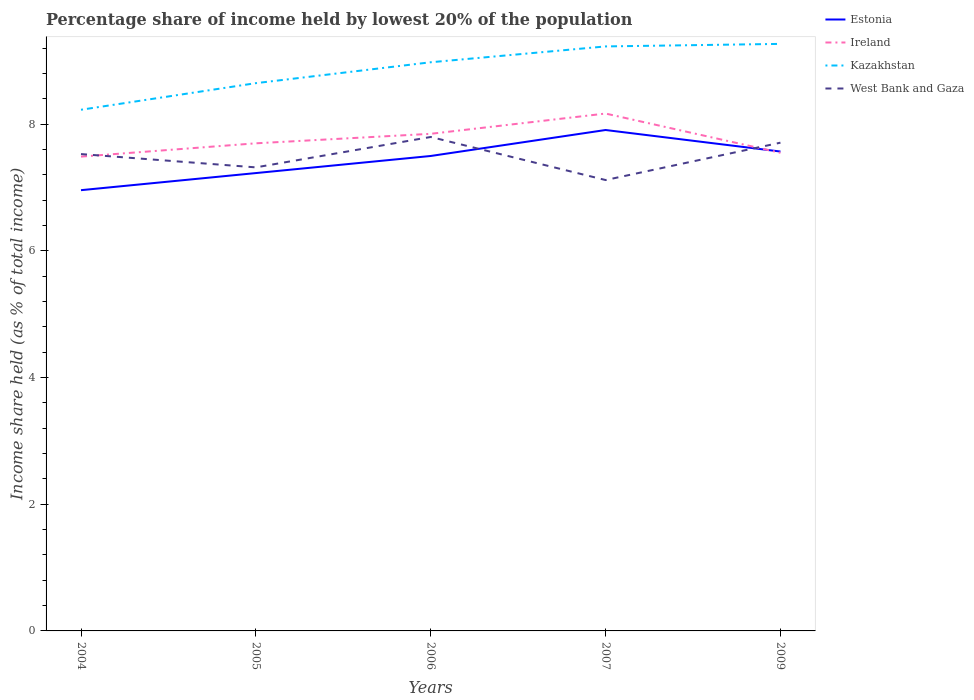How many different coloured lines are there?
Your response must be concise. 4. Does the line corresponding to Estonia intersect with the line corresponding to Kazakhstan?
Keep it short and to the point. No. Across all years, what is the maximum percentage share of income held by lowest 20% of the population in Kazakhstan?
Keep it short and to the point. 8.23. In which year was the percentage share of income held by lowest 20% of the population in Kazakhstan maximum?
Make the answer very short. 2004. What is the total percentage share of income held by lowest 20% of the population in West Bank and Gaza in the graph?
Keep it short and to the point. -0.27. What is the difference between the highest and the second highest percentage share of income held by lowest 20% of the population in Kazakhstan?
Offer a very short reply. 1.04. What is the difference between the highest and the lowest percentage share of income held by lowest 20% of the population in West Bank and Gaza?
Offer a terse response. 3. Does the graph contain grids?
Your response must be concise. No. How many legend labels are there?
Make the answer very short. 4. What is the title of the graph?
Provide a short and direct response. Percentage share of income held by lowest 20% of the population. Does "Suriname" appear as one of the legend labels in the graph?
Offer a very short reply. No. What is the label or title of the Y-axis?
Provide a succinct answer. Income share held (as % of total income). What is the Income share held (as % of total income) in Estonia in 2004?
Ensure brevity in your answer.  6.96. What is the Income share held (as % of total income) of Ireland in 2004?
Provide a succinct answer. 7.49. What is the Income share held (as % of total income) of Kazakhstan in 2004?
Your answer should be very brief. 8.23. What is the Income share held (as % of total income) in West Bank and Gaza in 2004?
Provide a succinct answer. 7.53. What is the Income share held (as % of total income) of Estonia in 2005?
Your answer should be compact. 7.23. What is the Income share held (as % of total income) in Kazakhstan in 2005?
Keep it short and to the point. 8.65. What is the Income share held (as % of total income) in West Bank and Gaza in 2005?
Ensure brevity in your answer.  7.32. What is the Income share held (as % of total income) of Ireland in 2006?
Offer a terse response. 7.85. What is the Income share held (as % of total income) in Kazakhstan in 2006?
Provide a short and direct response. 8.98. What is the Income share held (as % of total income) of Estonia in 2007?
Keep it short and to the point. 7.91. What is the Income share held (as % of total income) in Ireland in 2007?
Provide a succinct answer. 8.17. What is the Income share held (as % of total income) in Kazakhstan in 2007?
Make the answer very short. 9.23. What is the Income share held (as % of total income) in West Bank and Gaza in 2007?
Keep it short and to the point. 7.12. What is the Income share held (as % of total income) of Estonia in 2009?
Offer a very short reply. 7.57. What is the Income share held (as % of total income) in Ireland in 2009?
Ensure brevity in your answer.  7.55. What is the Income share held (as % of total income) of Kazakhstan in 2009?
Your response must be concise. 9.27. What is the Income share held (as % of total income) of West Bank and Gaza in 2009?
Your answer should be compact. 7.71. Across all years, what is the maximum Income share held (as % of total income) in Estonia?
Provide a succinct answer. 7.91. Across all years, what is the maximum Income share held (as % of total income) in Ireland?
Offer a terse response. 8.17. Across all years, what is the maximum Income share held (as % of total income) in Kazakhstan?
Provide a succinct answer. 9.27. Across all years, what is the minimum Income share held (as % of total income) of Estonia?
Offer a terse response. 6.96. Across all years, what is the minimum Income share held (as % of total income) in Ireland?
Give a very brief answer. 7.49. Across all years, what is the minimum Income share held (as % of total income) in Kazakhstan?
Keep it short and to the point. 8.23. Across all years, what is the minimum Income share held (as % of total income) of West Bank and Gaza?
Provide a short and direct response. 7.12. What is the total Income share held (as % of total income) in Estonia in the graph?
Provide a succinct answer. 37.17. What is the total Income share held (as % of total income) in Ireland in the graph?
Give a very brief answer. 38.76. What is the total Income share held (as % of total income) in Kazakhstan in the graph?
Give a very brief answer. 44.36. What is the total Income share held (as % of total income) in West Bank and Gaza in the graph?
Your answer should be compact. 37.48. What is the difference between the Income share held (as % of total income) of Estonia in 2004 and that in 2005?
Offer a terse response. -0.27. What is the difference between the Income share held (as % of total income) in Ireland in 2004 and that in 2005?
Offer a terse response. -0.21. What is the difference between the Income share held (as % of total income) in Kazakhstan in 2004 and that in 2005?
Offer a very short reply. -0.42. What is the difference between the Income share held (as % of total income) of West Bank and Gaza in 2004 and that in 2005?
Your answer should be very brief. 0.21. What is the difference between the Income share held (as % of total income) of Estonia in 2004 and that in 2006?
Give a very brief answer. -0.54. What is the difference between the Income share held (as % of total income) of Ireland in 2004 and that in 2006?
Provide a short and direct response. -0.36. What is the difference between the Income share held (as % of total income) of Kazakhstan in 2004 and that in 2006?
Provide a succinct answer. -0.75. What is the difference between the Income share held (as % of total income) of West Bank and Gaza in 2004 and that in 2006?
Your answer should be very brief. -0.27. What is the difference between the Income share held (as % of total income) of Estonia in 2004 and that in 2007?
Provide a succinct answer. -0.95. What is the difference between the Income share held (as % of total income) of Ireland in 2004 and that in 2007?
Give a very brief answer. -0.68. What is the difference between the Income share held (as % of total income) of Kazakhstan in 2004 and that in 2007?
Give a very brief answer. -1. What is the difference between the Income share held (as % of total income) of West Bank and Gaza in 2004 and that in 2007?
Ensure brevity in your answer.  0.41. What is the difference between the Income share held (as % of total income) in Estonia in 2004 and that in 2009?
Make the answer very short. -0.61. What is the difference between the Income share held (as % of total income) in Ireland in 2004 and that in 2009?
Give a very brief answer. -0.06. What is the difference between the Income share held (as % of total income) of Kazakhstan in 2004 and that in 2009?
Give a very brief answer. -1.04. What is the difference between the Income share held (as % of total income) of West Bank and Gaza in 2004 and that in 2009?
Keep it short and to the point. -0.18. What is the difference between the Income share held (as % of total income) of Estonia in 2005 and that in 2006?
Ensure brevity in your answer.  -0.27. What is the difference between the Income share held (as % of total income) of Ireland in 2005 and that in 2006?
Offer a terse response. -0.15. What is the difference between the Income share held (as % of total income) of Kazakhstan in 2005 and that in 2006?
Keep it short and to the point. -0.33. What is the difference between the Income share held (as % of total income) in West Bank and Gaza in 2005 and that in 2006?
Make the answer very short. -0.48. What is the difference between the Income share held (as % of total income) of Estonia in 2005 and that in 2007?
Your answer should be compact. -0.68. What is the difference between the Income share held (as % of total income) in Ireland in 2005 and that in 2007?
Your answer should be compact. -0.47. What is the difference between the Income share held (as % of total income) of Kazakhstan in 2005 and that in 2007?
Make the answer very short. -0.58. What is the difference between the Income share held (as % of total income) of Estonia in 2005 and that in 2009?
Ensure brevity in your answer.  -0.34. What is the difference between the Income share held (as % of total income) of Kazakhstan in 2005 and that in 2009?
Provide a short and direct response. -0.62. What is the difference between the Income share held (as % of total income) in West Bank and Gaza in 2005 and that in 2009?
Make the answer very short. -0.39. What is the difference between the Income share held (as % of total income) in Estonia in 2006 and that in 2007?
Your answer should be compact. -0.41. What is the difference between the Income share held (as % of total income) of Ireland in 2006 and that in 2007?
Offer a very short reply. -0.32. What is the difference between the Income share held (as % of total income) in Kazakhstan in 2006 and that in 2007?
Keep it short and to the point. -0.25. What is the difference between the Income share held (as % of total income) in West Bank and Gaza in 2006 and that in 2007?
Make the answer very short. 0.68. What is the difference between the Income share held (as % of total income) in Estonia in 2006 and that in 2009?
Offer a very short reply. -0.07. What is the difference between the Income share held (as % of total income) in Ireland in 2006 and that in 2009?
Offer a terse response. 0.3. What is the difference between the Income share held (as % of total income) in Kazakhstan in 2006 and that in 2009?
Provide a short and direct response. -0.29. What is the difference between the Income share held (as % of total income) of West Bank and Gaza in 2006 and that in 2009?
Offer a terse response. 0.09. What is the difference between the Income share held (as % of total income) in Estonia in 2007 and that in 2009?
Offer a very short reply. 0.34. What is the difference between the Income share held (as % of total income) of Ireland in 2007 and that in 2009?
Your answer should be compact. 0.62. What is the difference between the Income share held (as % of total income) in Kazakhstan in 2007 and that in 2009?
Provide a succinct answer. -0.04. What is the difference between the Income share held (as % of total income) of West Bank and Gaza in 2007 and that in 2009?
Your answer should be very brief. -0.59. What is the difference between the Income share held (as % of total income) in Estonia in 2004 and the Income share held (as % of total income) in Ireland in 2005?
Offer a very short reply. -0.74. What is the difference between the Income share held (as % of total income) in Estonia in 2004 and the Income share held (as % of total income) in Kazakhstan in 2005?
Your answer should be very brief. -1.69. What is the difference between the Income share held (as % of total income) of Estonia in 2004 and the Income share held (as % of total income) of West Bank and Gaza in 2005?
Your answer should be compact. -0.36. What is the difference between the Income share held (as % of total income) in Ireland in 2004 and the Income share held (as % of total income) in Kazakhstan in 2005?
Give a very brief answer. -1.16. What is the difference between the Income share held (as % of total income) of Ireland in 2004 and the Income share held (as % of total income) of West Bank and Gaza in 2005?
Give a very brief answer. 0.17. What is the difference between the Income share held (as % of total income) of Kazakhstan in 2004 and the Income share held (as % of total income) of West Bank and Gaza in 2005?
Your answer should be compact. 0.91. What is the difference between the Income share held (as % of total income) in Estonia in 2004 and the Income share held (as % of total income) in Ireland in 2006?
Ensure brevity in your answer.  -0.89. What is the difference between the Income share held (as % of total income) in Estonia in 2004 and the Income share held (as % of total income) in Kazakhstan in 2006?
Give a very brief answer. -2.02. What is the difference between the Income share held (as % of total income) in Estonia in 2004 and the Income share held (as % of total income) in West Bank and Gaza in 2006?
Make the answer very short. -0.84. What is the difference between the Income share held (as % of total income) in Ireland in 2004 and the Income share held (as % of total income) in Kazakhstan in 2006?
Provide a succinct answer. -1.49. What is the difference between the Income share held (as % of total income) in Ireland in 2004 and the Income share held (as % of total income) in West Bank and Gaza in 2006?
Offer a terse response. -0.31. What is the difference between the Income share held (as % of total income) of Kazakhstan in 2004 and the Income share held (as % of total income) of West Bank and Gaza in 2006?
Keep it short and to the point. 0.43. What is the difference between the Income share held (as % of total income) in Estonia in 2004 and the Income share held (as % of total income) in Ireland in 2007?
Offer a terse response. -1.21. What is the difference between the Income share held (as % of total income) in Estonia in 2004 and the Income share held (as % of total income) in Kazakhstan in 2007?
Provide a short and direct response. -2.27. What is the difference between the Income share held (as % of total income) in Estonia in 2004 and the Income share held (as % of total income) in West Bank and Gaza in 2007?
Offer a terse response. -0.16. What is the difference between the Income share held (as % of total income) of Ireland in 2004 and the Income share held (as % of total income) of Kazakhstan in 2007?
Give a very brief answer. -1.74. What is the difference between the Income share held (as % of total income) in Ireland in 2004 and the Income share held (as % of total income) in West Bank and Gaza in 2007?
Provide a short and direct response. 0.37. What is the difference between the Income share held (as % of total income) in Kazakhstan in 2004 and the Income share held (as % of total income) in West Bank and Gaza in 2007?
Give a very brief answer. 1.11. What is the difference between the Income share held (as % of total income) of Estonia in 2004 and the Income share held (as % of total income) of Ireland in 2009?
Ensure brevity in your answer.  -0.59. What is the difference between the Income share held (as % of total income) in Estonia in 2004 and the Income share held (as % of total income) in Kazakhstan in 2009?
Give a very brief answer. -2.31. What is the difference between the Income share held (as % of total income) of Estonia in 2004 and the Income share held (as % of total income) of West Bank and Gaza in 2009?
Make the answer very short. -0.75. What is the difference between the Income share held (as % of total income) of Ireland in 2004 and the Income share held (as % of total income) of Kazakhstan in 2009?
Give a very brief answer. -1.78. What is the difference between the Income share held (as % of total income) of Ireland in 2004 and the Income share held (as % of total income) of West Bank and Gaza in 2009?
Make the answer very short. -0.22. What is the difference between the Income share held (as % of total income) of Kazakhstan in 2004 and the Income share held (as % of total income) of West Bank and Gaza in 2009?
Provide a succinct answer. 0.52. What is the difference between the Income share held (as % of total income) of Estonia in 2005 and the Income share held (as % of total income) of Ireland in 2006?
Provide a short and direct response. -0.62. What is the difference between the Income share held (as % of total income) of Estonia in 2005 and the Income share held (as % of total income) of Kazakhstan in 2006?
Your answer should be very brief. -1.75. What is the difference between the Income share held (as % of total income) in Estonia in 2005 and the Income share held (as % of total income) in West Bank and Gaza in 2006?
Make the answer very short. -0.57. What is the difference between the Income share held (as % of total income) of Ireland in 2005 and the Income share held (as % of total income) of Kazakhstan in 2006?
Keep it short and to the point. -1.28. What is the difference between the Income share held (as % of total income) of Kazakhstan in 2005 and the Income share held (as % of total income) of West Bank and Gaza in 2006?
Provide a succinct answer. 0.85. What is the difference between the Income share held (as % of total income) of Estonia in 2005 and the Income share held (as % of total income) of Ireland in 2007?
Keep it short and to the point. -0.94. What is the difference between the Income share held (as % of total income) in Estonia in 2005 and the Income share held (as % of total income) in Kazakhstan in 2007?
Your answer should be compact. -2. What is the difference between the Income share held (as % of total income) of Estonia in 2005 and the Income share held (as % of total income) of West Bank and Gaza in 2007?
Keep it short and to the point. 0.11. What is the difference between the Income share held (as % of total income) in Ireland in 2005 and the Income share held (as % of total income) in Kazakhstan in 2007?
Provide a short and direct response. -1.53. What is the difference between the Income share held (as % of total income) of Ireland in 2005 and the Income share held (as % of total income) of West Bank and Gaza in 2007?
Your answer should be compact. 0.58. What is the difference between the Income share held (as % of total income) of Kazakhstan in 2005 and the Income share held (as % of total income) of West Bank and Gaza in 2007?
Your answer should be compact. 1.53. What is the difference between the Income share held (as % of total income) in Estonia in 2005 and the Income share held (as % of total income) in Ireland in 2009?
Provide a succinct answer. -0.32. What is the difference between the Income share held (as % of total income) of Estonia in 2005 and the Income share held (as % of total income) of Kazakhstan in 2009?
Your answer should be very brief. -2.04. What is the difference between the Income share held (as % of total income) of Estonia in 2005 and the Income share held (as % of total income) of West Bank and Gaza in 2009?
Your response must be concise. -0.48. What is the difference between the Income share held (as % of total income) in Ireland in 2005 and the Income share held (as % of total income) in Kazakhstan in 2009?
Your answer should be compact. -1.57. What is the difference between the Income share held (as % of total income) of Ireland in 2005 and the Income share held (as % of total income) of West Bank and Gaza in 2009?
Provide a succinct answer. -0.01. What is the difference between the Income share held (as % of total income) of Kazakhstan in 2005 and the Income share held (as % of total income) of West Bank and Gaza in 2009?
Make the answer very short. 0.94. What is the difference between the Income share held (as % of total income) of Estonia in 2006 and the Income share held (as % of total income) of Ireland in 2007?
Give a very brief answer. -0.67. What is the difference between the Income share held (as % of total income) in Estonia in 2006 and the Income share held (as % of total income) in Kazakhstan in 2007?
Ensure brevity in your answer.  -1.73. What is the difference between the Income share held (as % of total income) of Estonia in 2006 and the Income share held (as % of total income) of West Bank and Gaza in 2007?
Ensure brevity in your answer.  0.38. What is the difference between the Income share held (as % of total income) of Ireland in 2006 and the Income share held (as % of total income) of Kazakhstan in 2007?
Give a very brief answer. -1.38. What is the difference between the Income share held (as % of total income) in Ireland in 2006 and the Income share held (as % of total income) in West Bank and Gaza in 2007?
Your answer should be very brief. 0.73. What is the difference between the Income share held (as % of total income) of Kazakhstan in 2006 and the Income share held (as % of total income) of West Bank and Gaza in 2007?
Your response must be concise. 1.86. What is the difference between the Income share held (as % of total income) of Estonia in 2006 and the Income share held (as % of total income) of Kazakhstan in 2009?
Offer a very short reply. -1.77. What is the difference between the Income share held (as % of total income) in Estonia in 2006 and the Income share held (as % of total income) in West Bank and Gaza in 2009?
Give a very brief answer. -0.21. What is the difference between the Income share held (as % of total income) of Ireland in 2006 and the Income share held (as % of total income) of Kazakhstan in 2009?
Make the answer very short. -1.42. What is the difference between the Income share held (as % of total income) of Ireland in 2006 and the Income share held (as % of total income) of West Bank and Gaza in 2009?
Provide a succinct answer. 0.14. What is the difference between the Income share held (as % of total income) in Kazakhstan in 2006 and the Income share held (as % of total income) in West Bank and Gaza in 2009?
Make the answer very short. 1.27. What is the difference between the Income share held (as % of total income) of Estonia in 2007 and the Income share held (as % of total income) of Ireland in 2009?
Your answer should be very brief. 0.36. What is the difference between the Income share held (as % of total income) in Estonia in 2007 and the Income share held (as % of total income) in Kazakhstan in 2009?
Make the answer very short. -1.36. What is the difference between the Income share held (as % of total income) of Ireland in 2007 and the Income share held (as % of total income) of Kazakhstan in 2009?
Offer a terse response. -1.1. What is the difference between the Income share held (as % of total income) in Ireland in 2007 and the Income share held (as % of total income) in West Bank and Gaza in 2009?
Your response must be concise. 0.46. What is the difference between the Income share held (as % of total income) of Kazakhstan in 2007 and the Income share held (as % of total income) of West Bank and Gaza in 2009?
Keep it short and to the point. 1.52. What is the average Income share held (as % of total income) of Estonia per year?
Keep it short and to the point. 7.43. What is the average Income share held (as % of total income) of Ireland per year?
Your answer should be compact. 7.75. What is the average Income share held (as % of total income) in Kazakhstan per year?
Your response must be concise. 8.87. What is the average Income share held (as % of total income) of West Bank and Gaza per year?
Your response must be concise. 7.5. In the year 2004, what is the difference between the Income share held (as % of total income) of Estonia and Income share held (as % of total income) of Ireland?
Give a very brief answer. -0.53. In the year 2004, what is the difference between the Income share held (as % of total income) of Estonia and Income share held (as % of total income) of Kazakhstan?
Keep it short and to the point. -1.27. In the year 2004, what is the difference between the Income share held (as % of total income) in Estonia and Income share held (as % of total income) in West Bank and Gaza?
Your answer should be very brief. -0.57. In the year 2004, what is the difference between the Income share held (as % of total income) of Ireland and Income share held (as % of total income) of Kazakhstan?
Offer a terse response. -0.74. In the year 2004, what is the difference between the Income share held (as % of total income) in Ireland and Income share held (as % of total income) in West Bank and Gaza?
Make the answer very short. -0.04. In the year 2005, what is the difference between the Income share held (as % of total income) of Estonia and Income share held (as % of total income) of Ireland?
Provide a short and direct response. -0.47. In the year 2005, what is the difference between the Income share held (as % of total income) in Estonia and Income share held (as % of total income) in Kazakhstan?
Your answer should be compact. -1.42. In the year 2005, what is the difference between the Income share held (as % of total income) in Estonia and Income share held (as % of total income) in West Bank and Gaza?
Give a very brief answer. -0.09. In the year 2005, what is the difference between the Income share held (as % of total income) of Ireland and Income share held (as % of total income) of Kazakhstan?
Your answer should be compact. -0.95. In the year 2005, what is the difference between the Income share held (as % of total income) in Ireland and Income share held (as % of total income) in West Bank and Gaza?
Your answer should be very brief. 0.38. In the year 2005, what is the difference between the Income share held (as % of total income) of Kazakhstan and Income share held (as % of total income) of West Bank and Gaza?
Keep it short and to the point. 1.33. In the year 2006, what is the difference between the Income share held (as % of total income) of Estonia and Income share held (as % of total income) of Ireland?
Your response must be concise. -0.35. In the year 2006, what is the difference between the Income share held (as % of total income) of Estonia and Income share held (as % of total income) of Kazakhstan?
Keep it short and to the point. -1.48. In the year 2006, what is the difference between the Income share held (as % of total income) of Estonia and Income share held (as % of total income) of West Bank and Gaza?
Provide a short and direct response. -0.3. In the year 2006, what is the difference between the Income share held (as % of total income) in Ireland and Income share held (as % of total income) in Kazakhstan?
Make the answer very short. -1.13. In the year 2006, what is the difference between the Income share held (as % of total income) in Kazakhstan and Income share held (as % of total income) in West Bank and Gaza?
Your answer should be compact. 1.18. In the year 2007, what is the difference between the Income share held (as % of total income) of Estonia and Income share held (as % of total income) of Ireland?
Keep it short and to the point. -0.26. In the year 2007, what is the difference between the Income share held (as % of total income) of Estonia and Income share held (as % of total income) of Kazakhstan?
Offer a terse response. -1.32. In the year 2007, what is the difference between the Income share held (as % of total income) in Estonia and Income share held (as % of total income) in West Bank and Gaza?
Offer a terse response. 0.79. In the year 2007, what is the difference between the Income share held (as % of total income) of Ireland and Income share held (as % of total income) of Kazakhstan?
Your response must be concise. -1.06. In the year 2007, what is the difference between the Income share held (as % of total income) in Kazakhstan and Income share held (as % of total income) in West Bank and Gaza?
Your response must be concise. 2.11. In the year 2009, what is the difference between the Income share held (as % of total income) of Estonia and Income share held (as % of total income) of Ireland?
Keep it short and to the point. 0.02. In the year 2009, what is the difference between the Income share held (as % of total income) of Estonia and Income share held (as % of total income) of West Bank and Gaza?
Offer a terse response. -0.14. In the year 2009, what is the difference between the Income share held (as % of total income) in Ireland and Income share held (as % of total income) in Kazakhstan?
Give a very brief answer. -1.72. In the year 2009, what is the difference between the Income share held (as % of total income) in Ireland and Income share held (as % of total income) in West Bank and Gaza?
Ensure brevity in your answer.  -0.16. In the year 2009, what is the difference between the Income share held (as % of total income) of Kazakhstan and Income share held (as % of total income) of West Bank and Gaza?
Give a very brief answer. 1.56. What is the ratio of the Income share held (as % of total income) of Estonia in 2004 to that in 2005?
Give a very brief answer. 0.96. What is the ratio of the Income share held (as % of total income) in Ireland in 2004 to that in 2005?
Offer a very short reply. 0.97. What is the ratio of the Income share held (as % of total income) of Kazakhstan in 2004 to that in 2005?
Your answer should be compact. 0.95. What is the ratio of the Income share held (as % of total income) of West Bank and Gaza in 2004 to that in 2005?
Give a very brief answer. 1.03. What is the ratio of the Income share held (as % of total income) in Estonia in 2004 to that in 2006?
Give a very brief answer. 0.93. What is the ratio of the Income share held (as % of total income) in Ireland in 2004 to that in 2006?
Your response must be concise. 0.95. What is the ratio of the Income share held (as % of total income) in Kazakhstan in 2004 to that in 2006?
Ensure brevity in your answer.  0.92. What is the ratio of the Income share held (as % of total income) of West Bank and Gaza in 2004 to that in 2006?
Give a very brief answer. 0.97. What is the ratio of the Income share held (as % of total income) in Estonia in 2004 to that in 2007?
Ensure brevity in your answer.  0.88. What is the ratio of the Income share held (as % of total income) of Ireland in 2004 to that in 2007?
Ensure brevity in your answer.  0.92. What is the ratio of the Income share held (as % of total income) of Kazakhstan in 2004 to that in 2007?
Provide a succinct answer. 0.89. What is the ratio of the Income share held (as % of total income) of West Bank and Gaza in 2004 to that in 2007?
Your response must be concise. 1.06. What is the ratio of the Income share held (as % of total income) of Estonia in 2004 to that in 2009?
Offer a terse response. 0.92. What is the ratio of the Income share held (as % of total income) of Ireland in 2004 to that in 2009?
Offer a very short reply. 0.99. What is the ratio of the Income share held (as % of total income) in Kazakhstan in 2004 to that in 2009?
Offer a terse response. 0.89. What is the ratio of the Income share held (as % of total income) of West Bank and Gaza in 2004 to that in 2009?
Your answer should be very brief. 0.98. What is the ratio of the Income share held (as % of total income) of Ireland in 2005 to that in 2006?
Make the answer very short. 0.98. What is the ratio of the Income share held (as % of total income) in Kazakhstan in 2005 to that in 2006?
Ensure brevity in your answer.  0.96. What is the ratio of the Income share held (as % of total income) in West Bank and Gaza in 2005 to that in 2006?
Provide a succinct answer. 0.94. What is the ratio of the Income share held (as % of total income) in Estonia in 2005 to that in 2007?
Your answer should be compact. 0.91. What is the ratio of the Income share held (as % of total income) in Ireland in 2005 to that in 2007?
Make the answer very short. 0.94. What is the ratio of the Income share held (as % of total income) in Kazakhstan in 2005 to that in 2007?
Your answer should be very brief. 0.94. What is the ratio of the Income share held (as % of total income) in West Bank and Gaza in 2005 to that in 2007?
Make the answer very short. 1.03. What is the ratio of the Income share held (as % of total income) of Estonia in 2005 to that in 2009?
Offer a terse response. 0.96. What is the ratio of the Income share held (as % of total income) in Ireland in 2005 to that in 2009?
Offer a very short reply. 1.02. What is the ratio of the Income share held (as % of total income) of Kazakhstan in 2005 to that in 2009?
Provide a succinct answer. 0.93. What is the ratio of the Income share held (as % of total income) in West Bank and Gaza in 2005 to that in 2009?
Offer a terse response. 0.95. What is the ratio of the Income share held (as % of total income) of Estonia in 2006 to that in 2007?
Give a very brief answer. 0.95. What is the ratio of the Income share held (as % of total income) in Ireland in 2006 to that in 2007?
Provide a short and direct response. 0.96. What is the ratio of the Income share held (as % of total income) in Kazakhstan in 2006 to that in 2007?
Give a very brief answer. 0.97. What is the ratio of the Income share held (as % of total income) of West Bank and Gaza in 2006 to that in 2007?
Your response must be concise. 1.1. What is the ratio of the Income share held (as % of total income) of Estonia in 2006 to that in 2009?
Offer a terse response. 0.99. What is the ratio of the Income share held (as % of total income) of Ireland in 2006 to that in 2009?
Offer a very short reply. 1.04. What is the ratio of the Income share held (as % of total income) of Kazakhstan in 2006 to that in 2009?
Your response must be concise. 0.97. What is the ratio of the Income share held (as % of total income) of West Bank and Gaza in 2006 to that in 2009?
Offer a terse response. 1.01. What is the ratio of the Income share held (as % of total income) in Estonia in 2007 to that in 2009?
Provide a short and direct response. 1.04. What is the ratio of the Income share held (as % of total income) of Ireland in 2007 to that in 2009?
Your response must be concise. 1.08. What is the ratio of the Income share held (as % of total income) of West Bank and Gaza in 2007 to that in 2009?
Give a very brief answer. 0.92. What is the difference between the highest and the second highest Income share held (as % of total income) of Estonia?
Provide a succinct answer. 0.34. What is the difference between the highest and the second highest Income share held (as % of total income) of Ireland?
Ensure brevity in your answer.  0.32. What is the difference between the highest and the second highest Income share held (as % of total income) in Kazakhstan?
Offer a very short reply. 0.04. What is the difference between the highest and the second highest Income share held (as % of total income) in West Bank and Gaza?
Your response must be concise. 0.09. What is the difference between the highest and the lowest Income share held (as % of total income) in Estonia?
Your response must be concise. 0.95. What is the difference between the highest and the lowest Income share held (as % of total income) in Ireland?
Offer a very short reply. 0.68. What is the difference between the highest and the lowest Income share held (as % of total income) in West Bank and Gaza?
Offer a terse response. 0.68. 